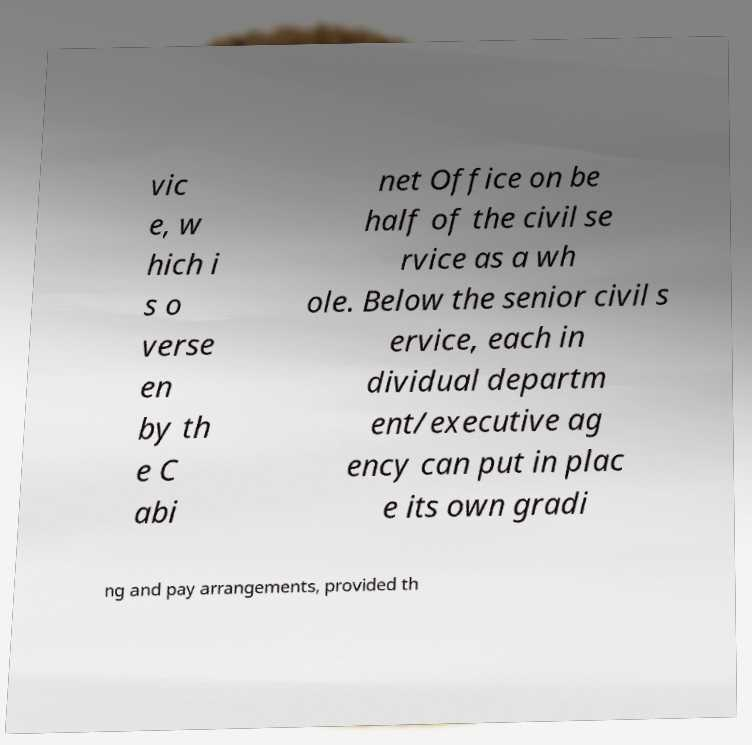Please read and relay the text visible in this image. What does it say? vic e, w hich i s o verse en by th e C abi net Office on be half of the civil se rvice as a wh ole. Below the senior civil s ervice, each in dividual departm ent/executive ag ency can put in plac e its own gradi ng and pay arrangements, provided th 